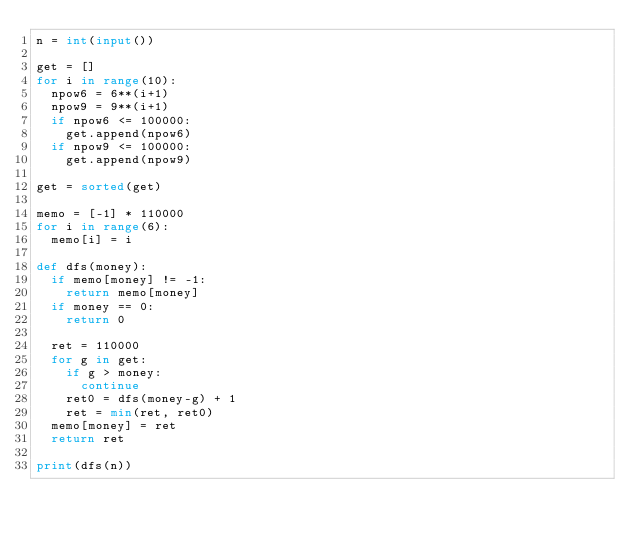Convert code to text. <code><loc_0><loc_0><loc_500><loc_500><_Python_>n = int(input())

get = []
for i in range(10):
  npow6 = 6**(i+1)
  npow9 = 9**(i+1)
  if npow6 <= 100000:
    get.append(npow6)
  if npow9 <= 100000:
    get.append(npow9)
  
get = sorted(get)

memo = [-1] * 110000
for i in range(6):
  memo[i] = i
  
def dfs(money):
  if memo[money] != -1:
    return memo[money]
  if money == 0:
    return 0
  
  ret = 110000
  for g in get:
    if g > money:
      continue
    ret0 = dfs(money-g) + 1
    ret = min(ret, ret0)
  memo[money] = ret
  return ret

print(dfs(n))</code> 